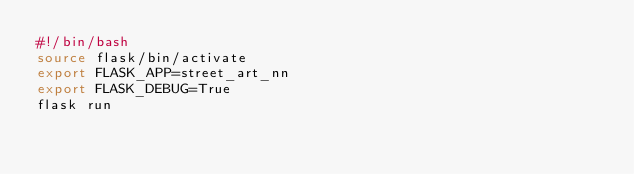<code> <loc_0><loc_0><loc_500><loc_500><_Bash_>#!/bin/bash
source flask/bin/activate
export FLASK_APP=street_art_nn
export FLASK_DEBUG=True
flask run
</code> 